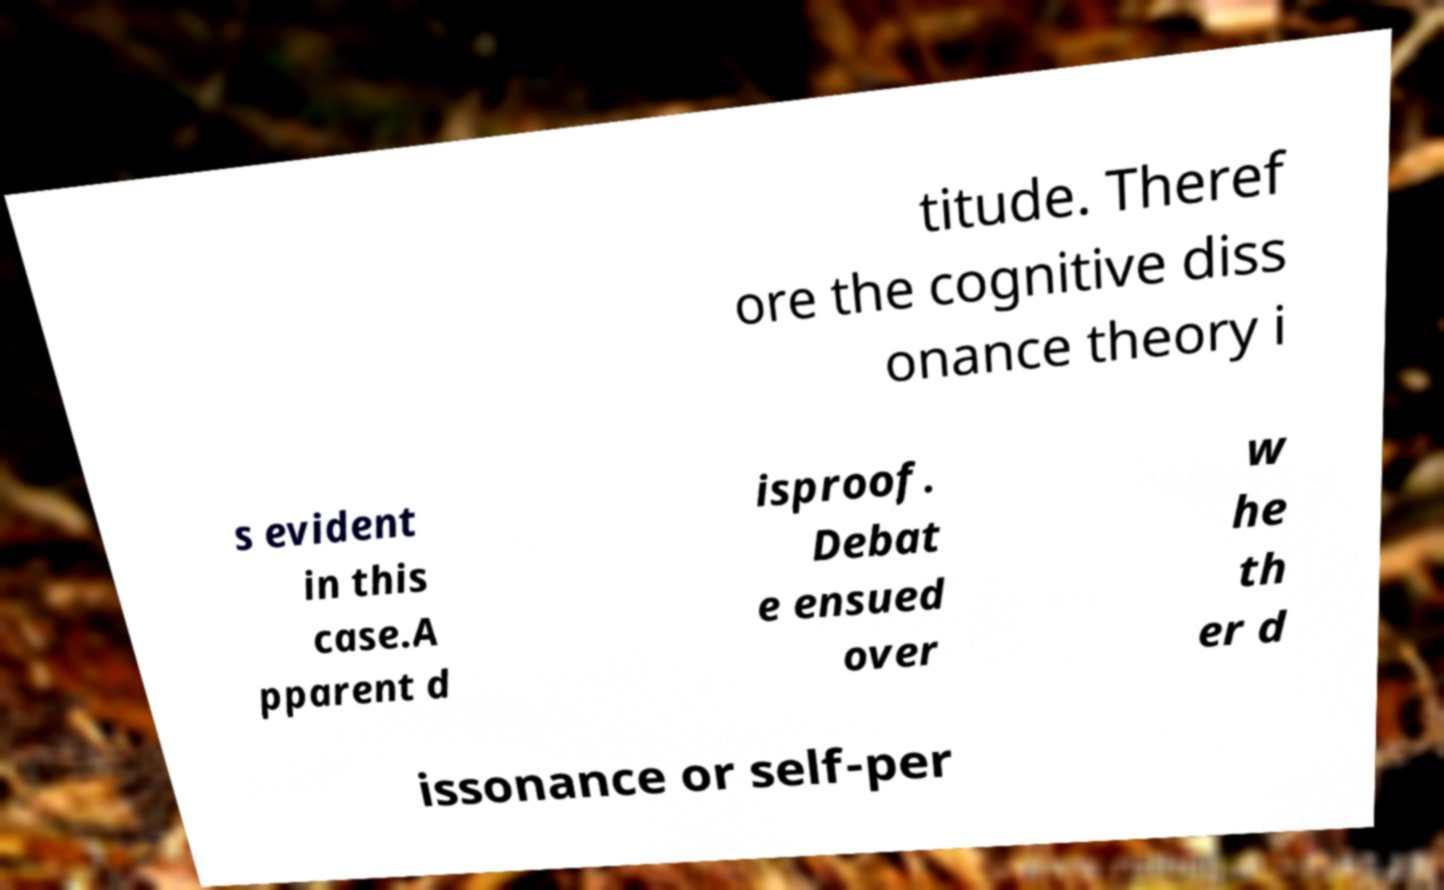Please read and relay the text visible in this image. What does it say? titude. Theref ore the cognitive diss onance theory i s evident in this case.A pparent d isproof. Debat e ensued over w he th er d issonance or self-per 